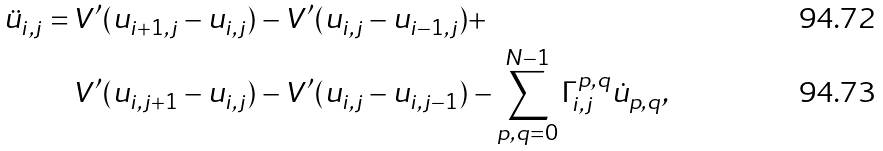Convert formula to latex. <formula><loc_0><loc_0><loc_500><loc_500>\ddot { u } _ { i , j } = \, & V ^ { \prime } ( u _ { i + 1 , j } - u _ { i , j } ) - V ^ { \prime } ( u _ { i , j } - u _ { i - 1 , j } ) + \\ & V ^ { \prime } ( u _ { i , j + 1 } - u _ { i , j } ) - V ^ { \prime } ( u _ { i , j } - u _ { i , j - 1 } ) - \sum _ { p , q = 0 } ^ { N - 1 } \Gamma ^ { p , q } _ { i , j } \dot { u } _ { p , q } ,</formula> 